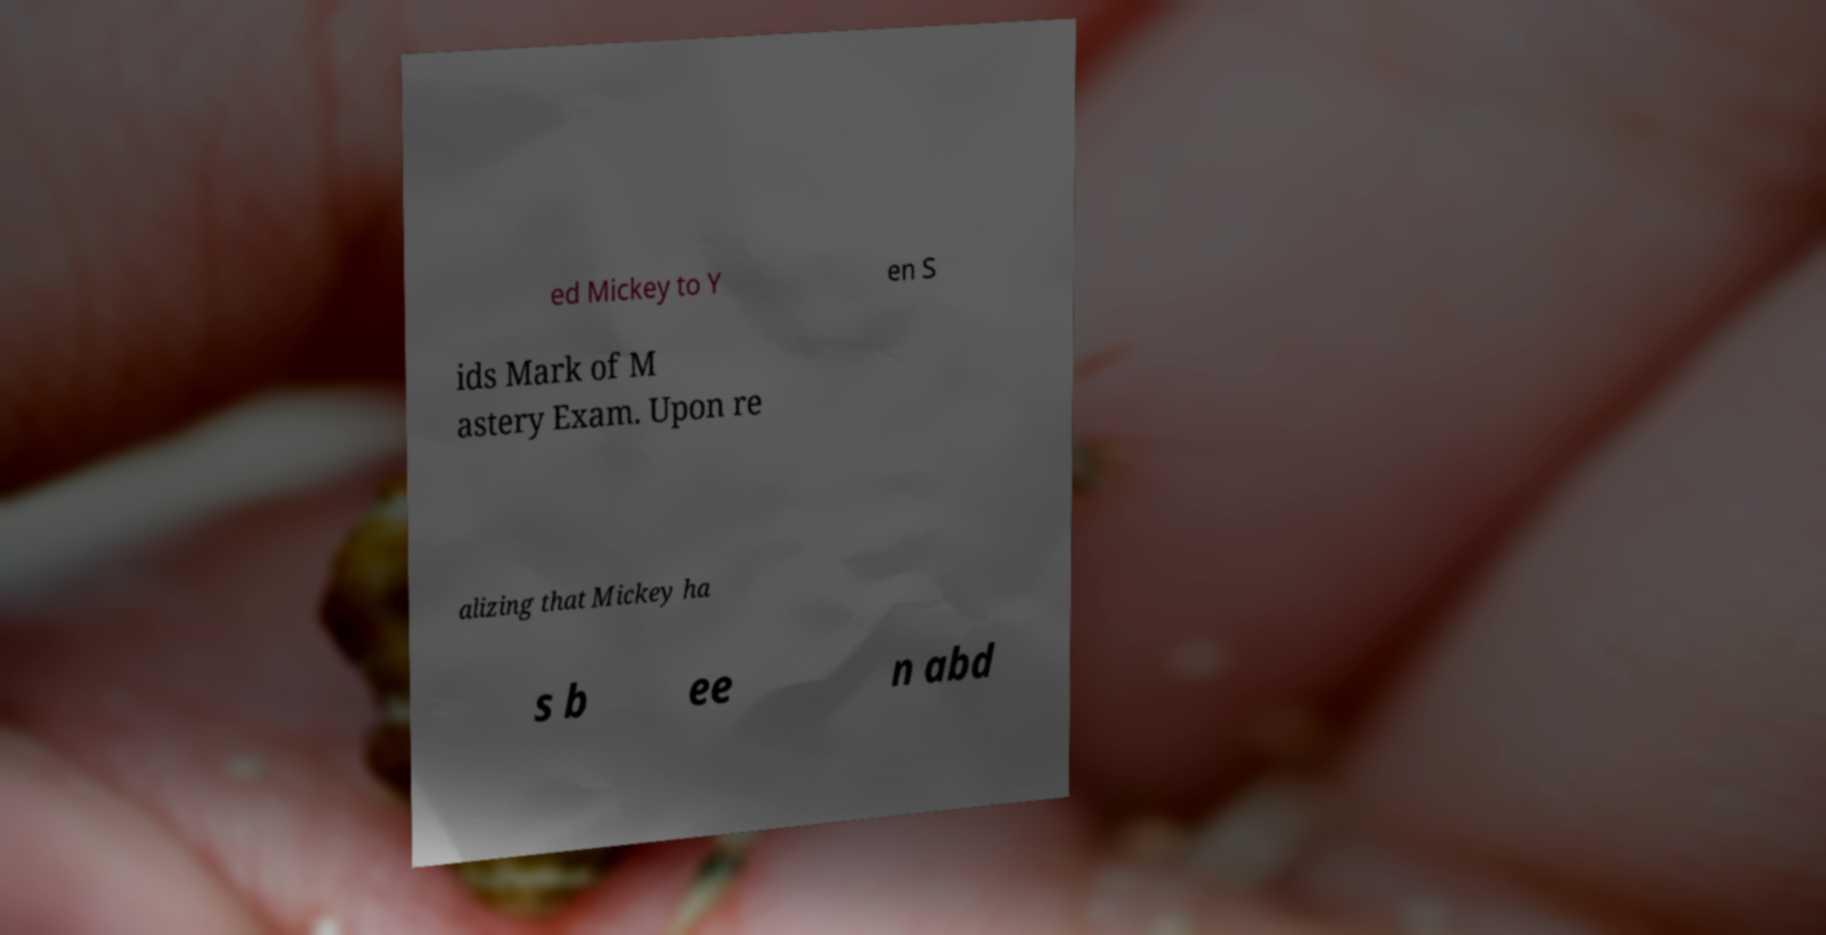Please identify and transcribe the text found in this image. ed Mickey to Y en S ids Mark of M astery Exam. Upon re alizing that Mickey ha s b ee n abd 